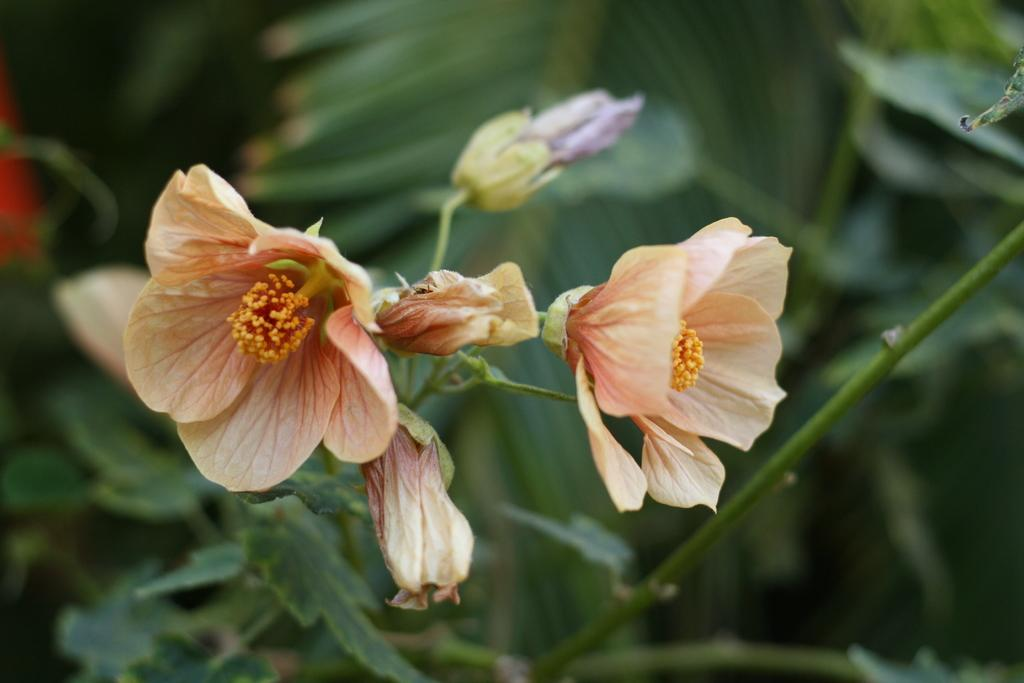What type of plants can be seen in the image? There are flowers and trees in the image. What part of the plants is visible in the image? There is a stem and leaves visible in the image. What type of protest is happening in the image? There is no protest present in the image; it features flowers, trees, a stem, and leaves. How many people are participating in the crowd in the image? There is no crowd present in the image; it features plants and their parts. 